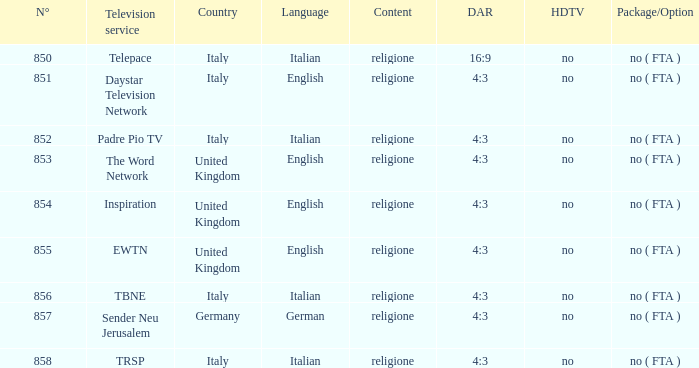0? TRSP. 